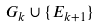<formula> <loc_0><loc_0><loc_500><loc_500>G _ { k } \cup \{ E _ { k + 1 } \}</formula> 